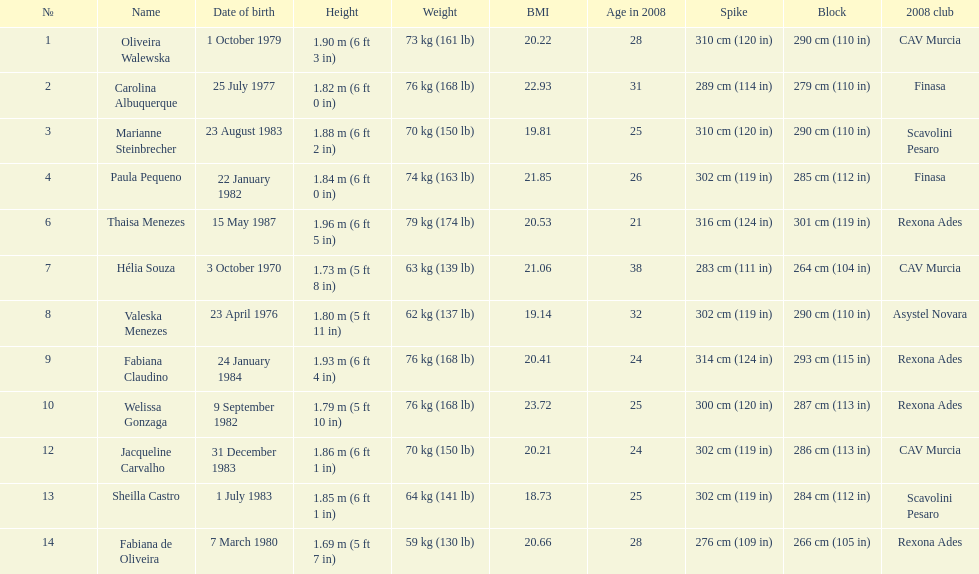Oliveira walewska has the same block as how many other players? 2. 